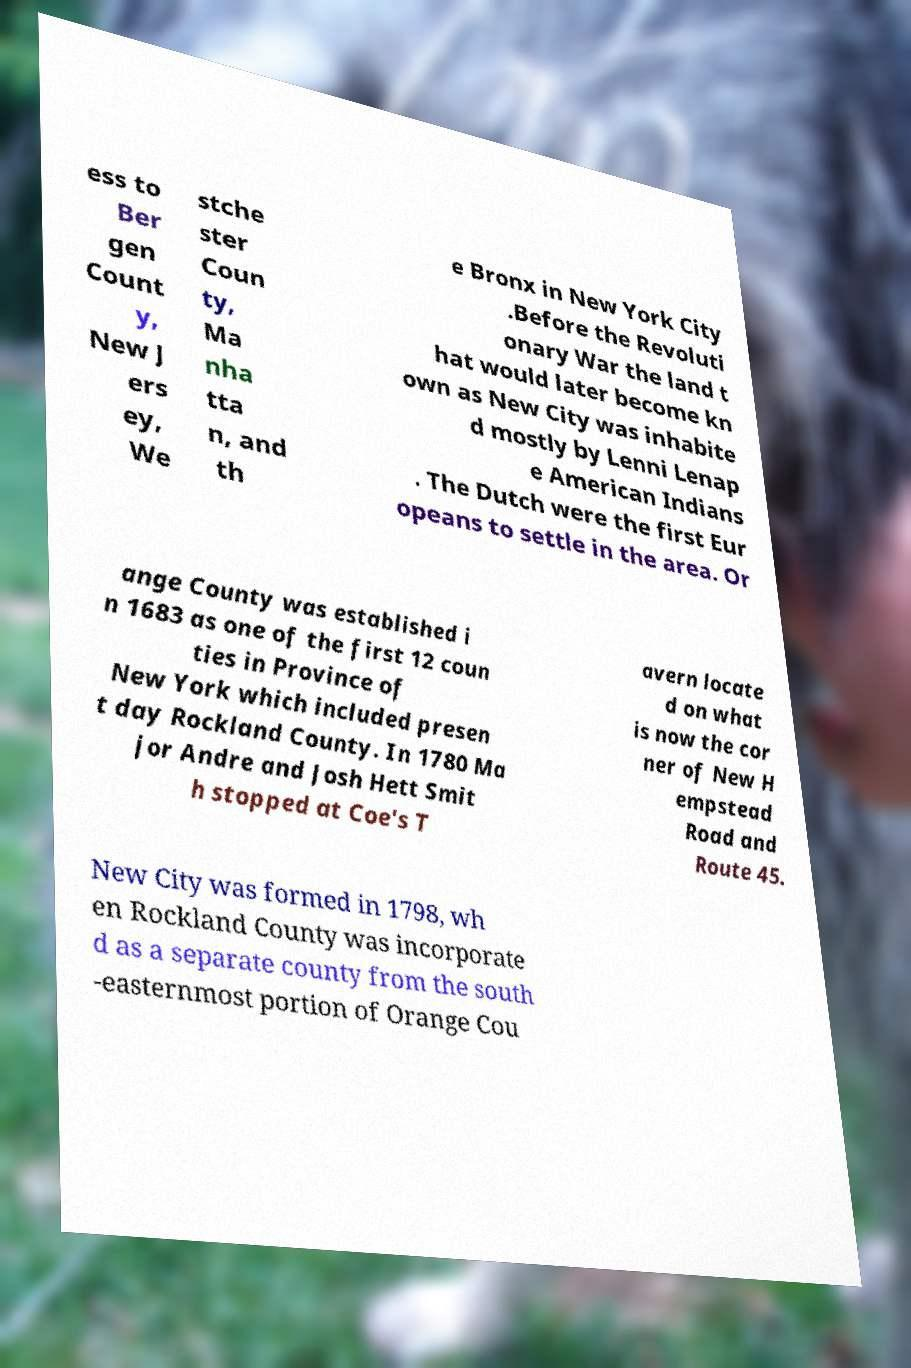Please read and relay the text visible in this image. What does it say? ess to Ber gen Count y, New J ers ey, We stche ster Coun ty, Ma nha tta n, and th e Bronx in New York City .Before the Revoluti onary War the land t hat would later become kn own as New City was inhabite d mostly by Lenni Lenap e American Indians . The Dutch were the first Eur opeans to settle in the area. Or ange County was established i n 1683 as one of the first 12 coun ties in Province of New York which included presen t day Rockland County. In 1780 Ma jor Andre and Josh Hett Smit h stopped at Coe's T avern locate d on what is now the cor ner of New H empstead Road and Route 45. New City was formed in 1798, wh en Rockland County was incorporate d as a separate county from the south -easternmost portion of Orange Cou 